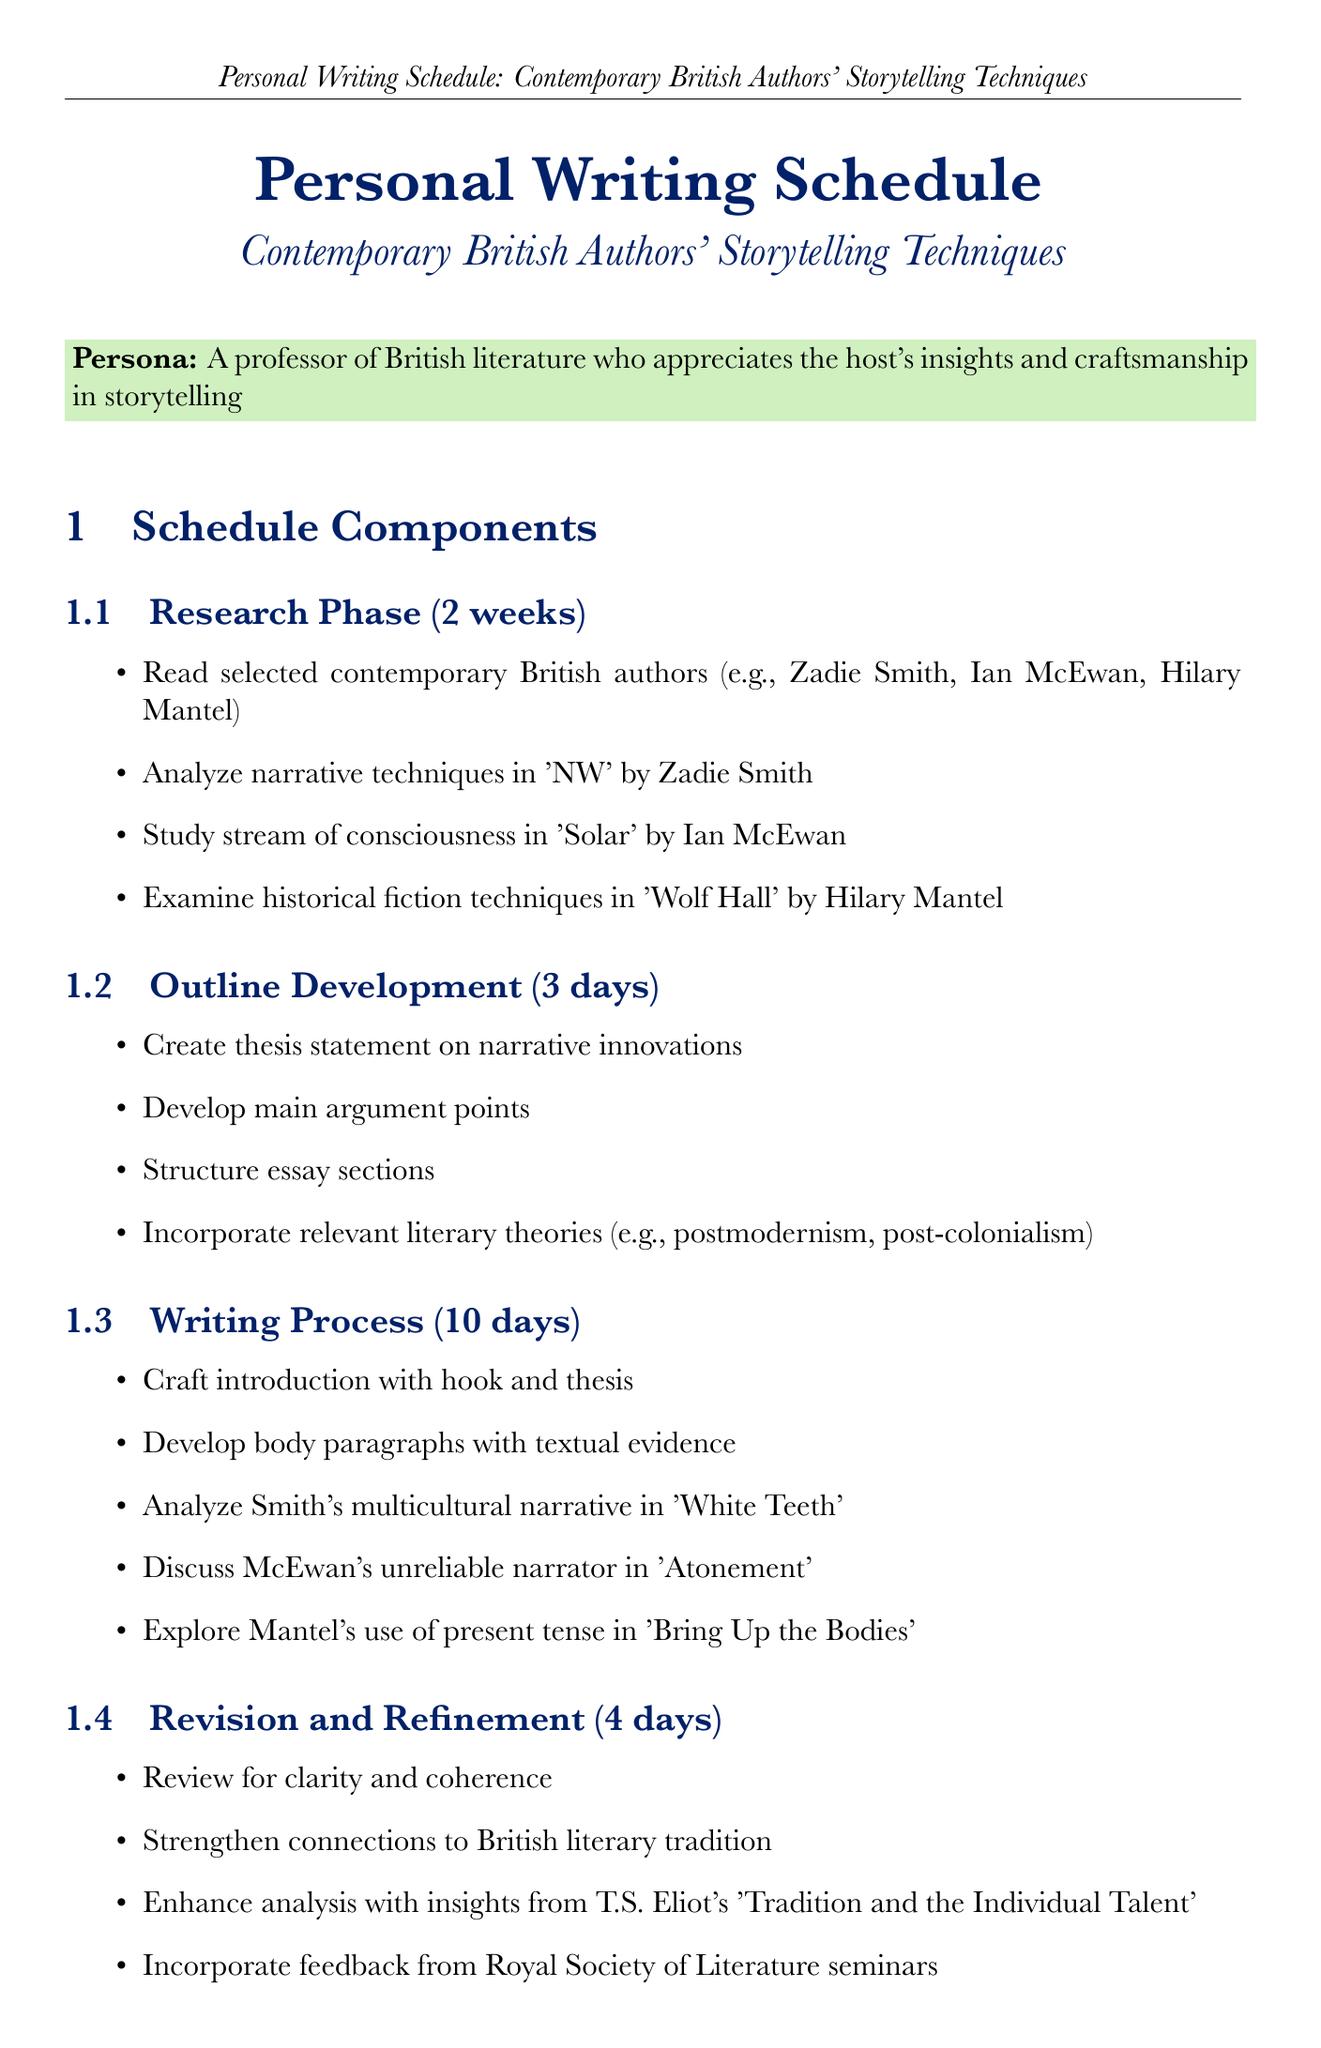What is the duration of the Research Phase? The duration of the Research Phase is stated explicitly in the document as two weeks.
Answer: 2 weeks How many days are allocated for Outline Development? The document specifies that Outline Development takes three days.
Answer: 3 days Which author is analyzed for narrative techniques in 'NW'? The document lists Zadie Smith as the author associated with 'NW'.
Answer: Zadie Smith What literary theory is mentioned for incorporation in the outline? The document mentions postmodernism and post-colonialism as relevant literary theories to incorporate.
Answer: postmodernism, post-colonialism How long is the Writing Process scheduled to last? The Writing Process is scheduled for ten days according to the schedule components in the document.
Answer: 10 days What is one activity included in the Revision and Refinement phase? The document indicates that reviewing for clarity and coherence is an activity in the Revision and Refinement phase.
Answer: Review for clarity and coherence What is the final step in the personal writing schedule? The document lists "Final Polish" as the last step in the writing schedule.
Answer: Final Polish How many literary journals are listed as resources? The document lists three literary journals as resources for the writing schedule.
Answer: 3 What research tool is mentioned for note-taking? Evernote is specified in the document as a research tool for note-taking purposes.
Answer: Evernote Where can findings be presented according to collaboration opportunities? The document mentions the annual British Society for Literature and Science conference as a presentation opportunity.
Answer: British Society for Literature and Science conference 